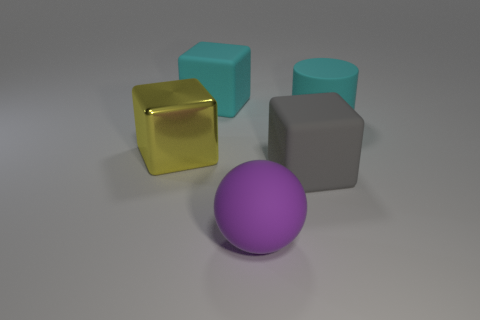Subtract all cyan rubber blocks. How many blocks are left? 2 Subtract all yellow cubes. How many cubes are left? 2 Subtract 1 balls. How many balls are left? 0 Add 4 large gray things. How many objects exist? 9 Add 5 blocks. How many blocks are left? 8 Add 4 large metal objects. How many large metal objects exist? 5 Subtract 0 brown balls. How many objects are left? 5 Subtract all cubes. How many objects are left? 2 Subtract all purple cylinders. Subtract all blue blocks. How many cylinders are left? 1 Subtract all large yellow metallic objects. Subtract all big gray objects. How many objects are left? 3 